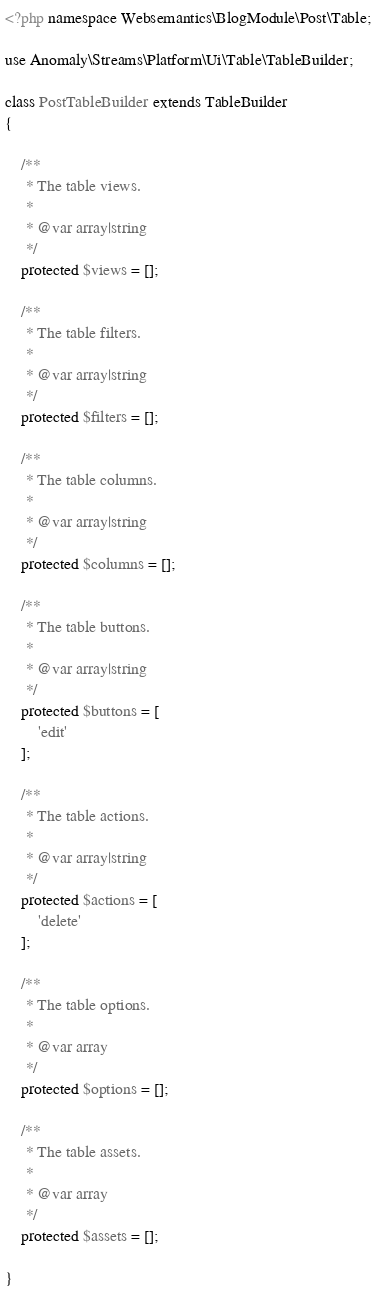<code> <loc_0><loc_0><loc_500><loc_500><_PHP_><?php namespace Websemantics\BlogModule\Post\Table;

use Anomaly\Streams\Platform\Ui\Table\TableBuilder;

class PostTableBuilder extends TableBuilder
{

    /**
     * The table views.
     *
     * @var array|string
     */
    protected $views = [];

    /**
     * The table filters.
     *
     * @var array|string
     */
    protected $filters = [];

    /**
     * The table columns.
     *
     * @var array|string
     */
    protected $columns = [];

    /**
     * The table buttons.
     *
     * @var array|string
     */
    protected $buttons = [
        'edit'
    ];

    /**
     * The table actions.
     *
     * @var array|string
     */
    protected $actions = [
        'delete'
    ];

    /**
     * The table options.
     *
     * @var array
     */
    protected $options = [];

    /**
     * The table assets.
     *
     * @var array
     */
    protected $assets = [];

}
</code> 